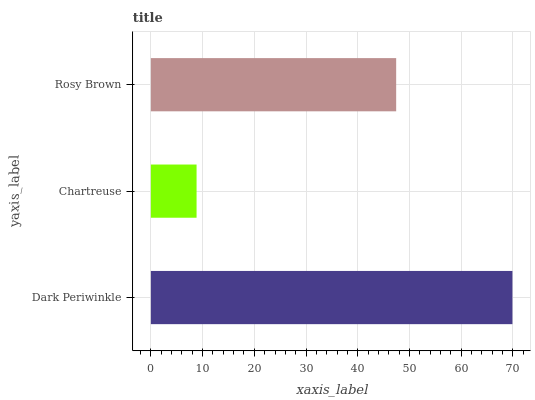Is Chartreuse the minimum?
Answer yes or no. Yes. Is Dark Periwinkle the maximum?
Answer yes or no. Yes. Is Rosy Brown the minimum?
Answer yes or no. No. Is Rosy Brown the maximum?
Answer yes or no. No. Is Rosy Brown greater than Chartreuse?
Answer yes or no. Yes. Is Chartreuse less than Rosy Brown?
Answer yes or no. Yes. Is Chartreuse greater than Rosy Brown?
Answer yes or no. No. Is Rosy Brown less than Chartreuse?
Answer yes or no. No. Is Rosy Brown the high median?
Answer yes or no. Yes. Is Rosy Brown the low median?
Answer yes or no. Yes. Is Dark Periwinkle the high median?
Answer yes or no. No. Is Chartreuse the low median?
Answer yes or no. No. 